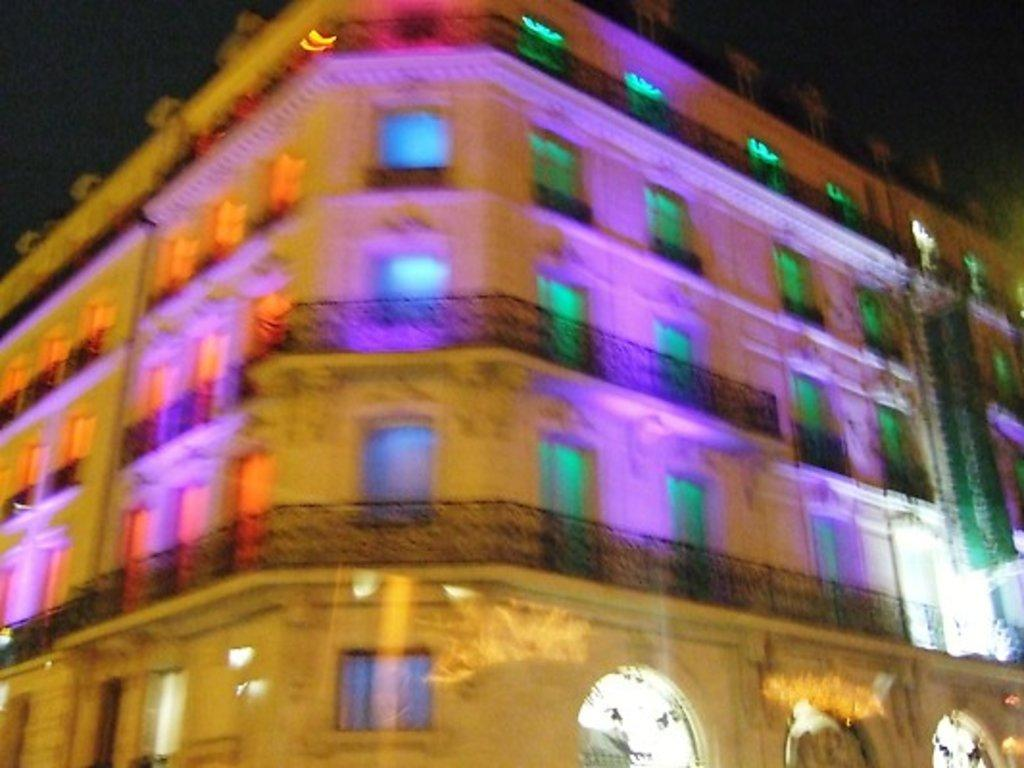What type of structure is present in the image? There is a building in the image. What are the main features of the building? The building has doors and windows. What can be seen in the background of the image? The sky is visible in the image. Can you determine the time of day the image was taken? The image may have been taken during night, as there is no indication of daylight. How many dogs are visible in the image? There are no dogs present in the image. Is the building in the image a jail? The image does not provide any information about the building's function, so it cannot be determined if it is a jail. What type of potato is being used as a decoration in the image? There is no potato present in the image. 